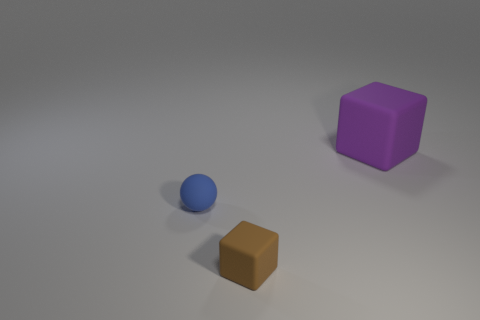Add 1 spheres. How many objects exist? 4 Subtract all brown blocks. How many blocks are left? 1 Subtract all balls. How many objects are left? 2 Subtract all yellow balls. Subtract all brown cylinders. How many balls are left? 1 Subtract all purple cubes. Subtract all blue balls. How many objects are left? 1 Add 3 balls. How many balls are left? 4 Add 2 large blue matte spheres. How many large blue matte spheres exist? 2 Subtract 0 gray blocks. How many objects are left? 3 